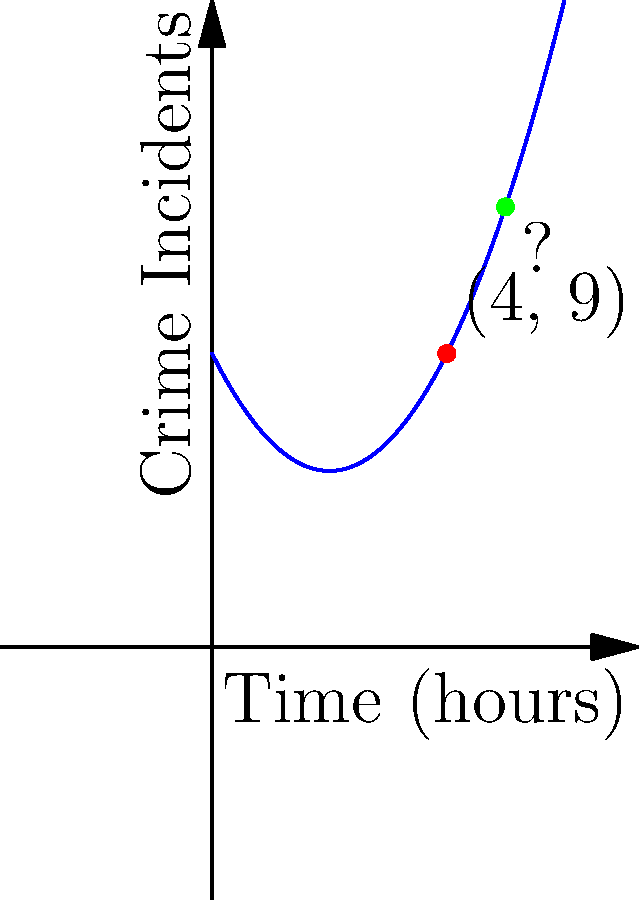Based on the polynomial regression curve of past crime incidents shown in the graph, what is the predicted number of crime incidents at the 5-hour mark? Round your answer to the nearest whole number. To solve this problem, we need to follow these steps:

1. Identify the polynomial function from the graph:
   The function appears to be a quadratic function of the form $f(x) = ax^2 + bx + c$

2. Use the given point (4, 9) to determine the function:
   $f(x) = 0.5x^2 - 2x + 5$

3. To find the number of incidents at the 5-hour mark, we need to calculate $f(5)$:

   $f(5) = 0.5(5)^2 - 2(5) + 5$
   $    = 0.5(25) - 10 + 5$
   $    = 12.5 - 10 + 5$
   $    = 7.5$

4. Rounding to the nearest whole number:
   7.5 rounds to 8

Therefore, the predicted number of crime incidents at the 5-hour mark is 8.
Answer: 8 